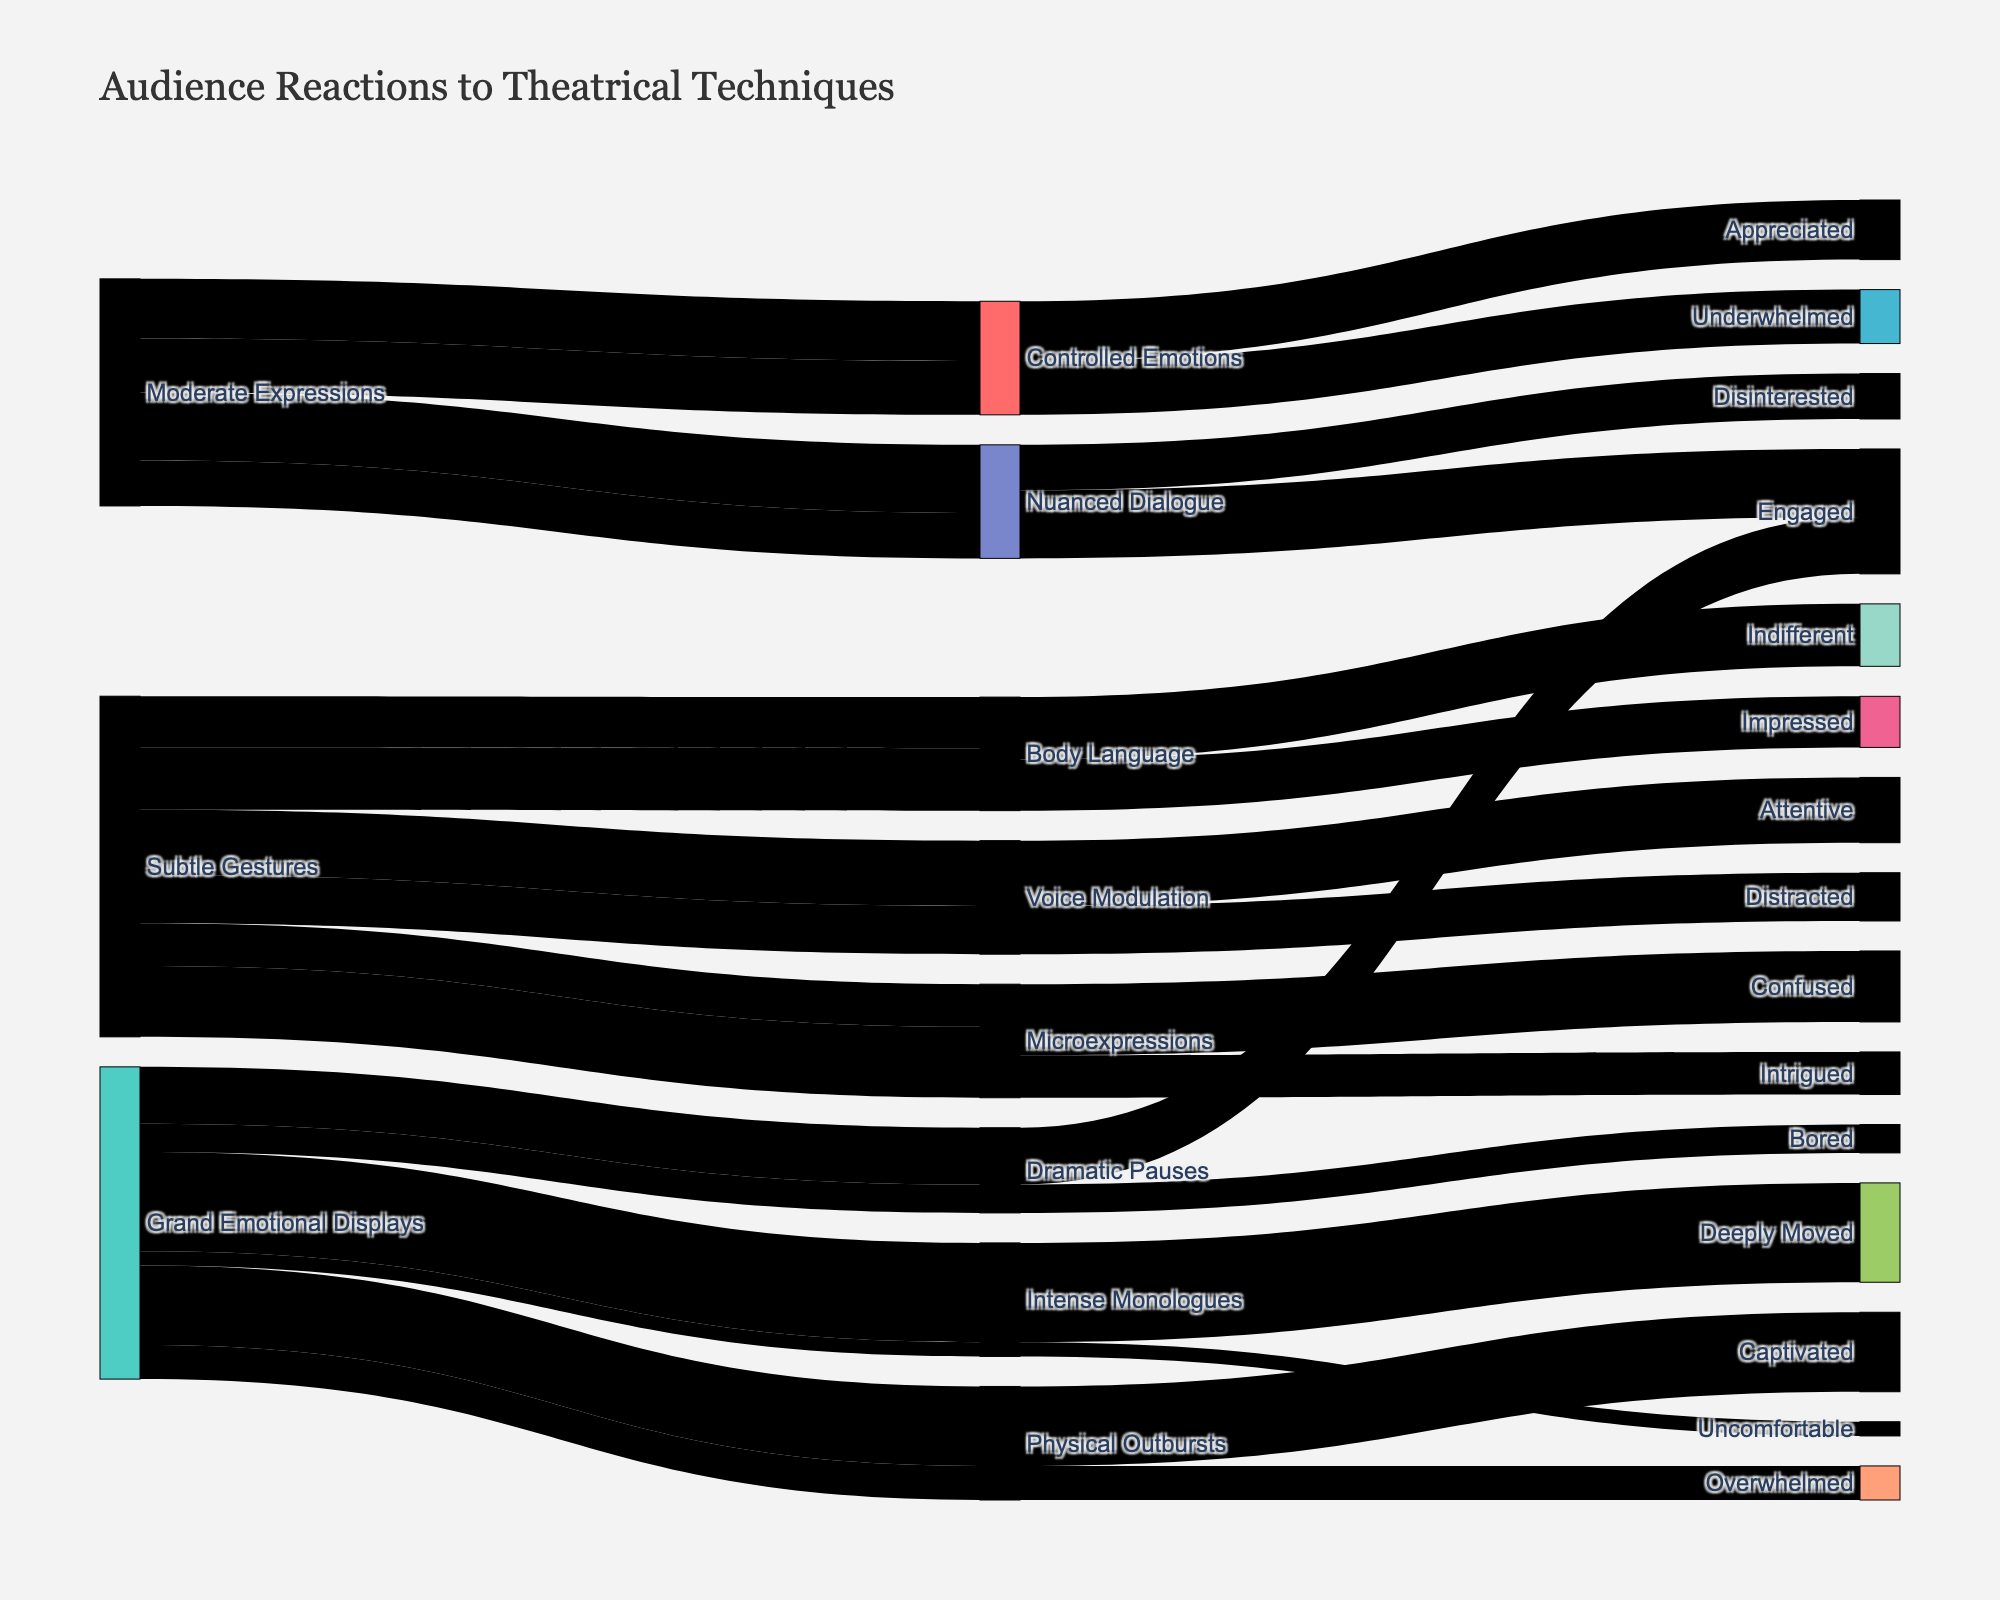What's the title of the figure? The title of the figure is generally located at the top and gives an overview of what the diagram is about. The title in this instance provides a summary of what is being depicted.
Answer: Audience Reactions to Theatrical Techniques What is the most common audience reaction to ‘Intense Monologues’? To find this, examine the links coming out from 'Intense Monologues' and see which reaction has the highest value associated. The highest value link represents the most common reaction.
Answer: Deeply Moved How many audience reactions are linked to the 'Subtle Gestures' source? Count the distinct audience reactions that can be traced back to the 'Subtle Gestures' source by observing the outgoing paths from this source and their endpoints.
Answer: 6 What is the difference in audience count between 'Engaged' reactions to 'Dramatic Pauses' and 'Bored' reactions to 'Dramatic Pauses'? First, identify the counts for 'Engaged' and 'Bored' reactions to 'Dramatic Pauses' which are 200 and 100 respectively. The difference is 200 - 100.
Answer: 100 Which technique under 'Subtle Gestures' has the highest count of 'Confused' reactions? Look for the path from the 'Subtle Gestures' source to the 'Confused' reaction and identify which technique it passes through, observing the value associated with these links.
Answer: Microexpressions How does the number of 'Overwhelmed' reactions to 'Physical Outbursts' compare to 'Uncomfortable' reactions to 'Intense Monologues'? Examine and compare the counts of 'Overwhelmed' (120) and 'Uncomfortable' (50). 'Physical Outbursts' to 'Overwhelmed' has a higher count.
Answer: Higher What is the average audience reaction count for 'Controlled Emotions'? To find the average, add the counts for all reactions to 'Controlled Emotions' (210 + 190 = 400) and divide by the number of reactions (2).
Answer: 200 Are 'Nuanced Dialogue' techniques more engaging than 'Voice Modulation' techniques? Compare the count of 'Engaged' reactions to 'Nuanced Dialogue' (240) with 'Attentive' reactions to 'Voice Modulation' (230).
Answer: Yes How many total people were 'Impressed' by 'Body Language' techniques? Directly check the total count associated with the 'Impressed' reaction linked to 'Body Language' based on the diagram.
Answer: 180 